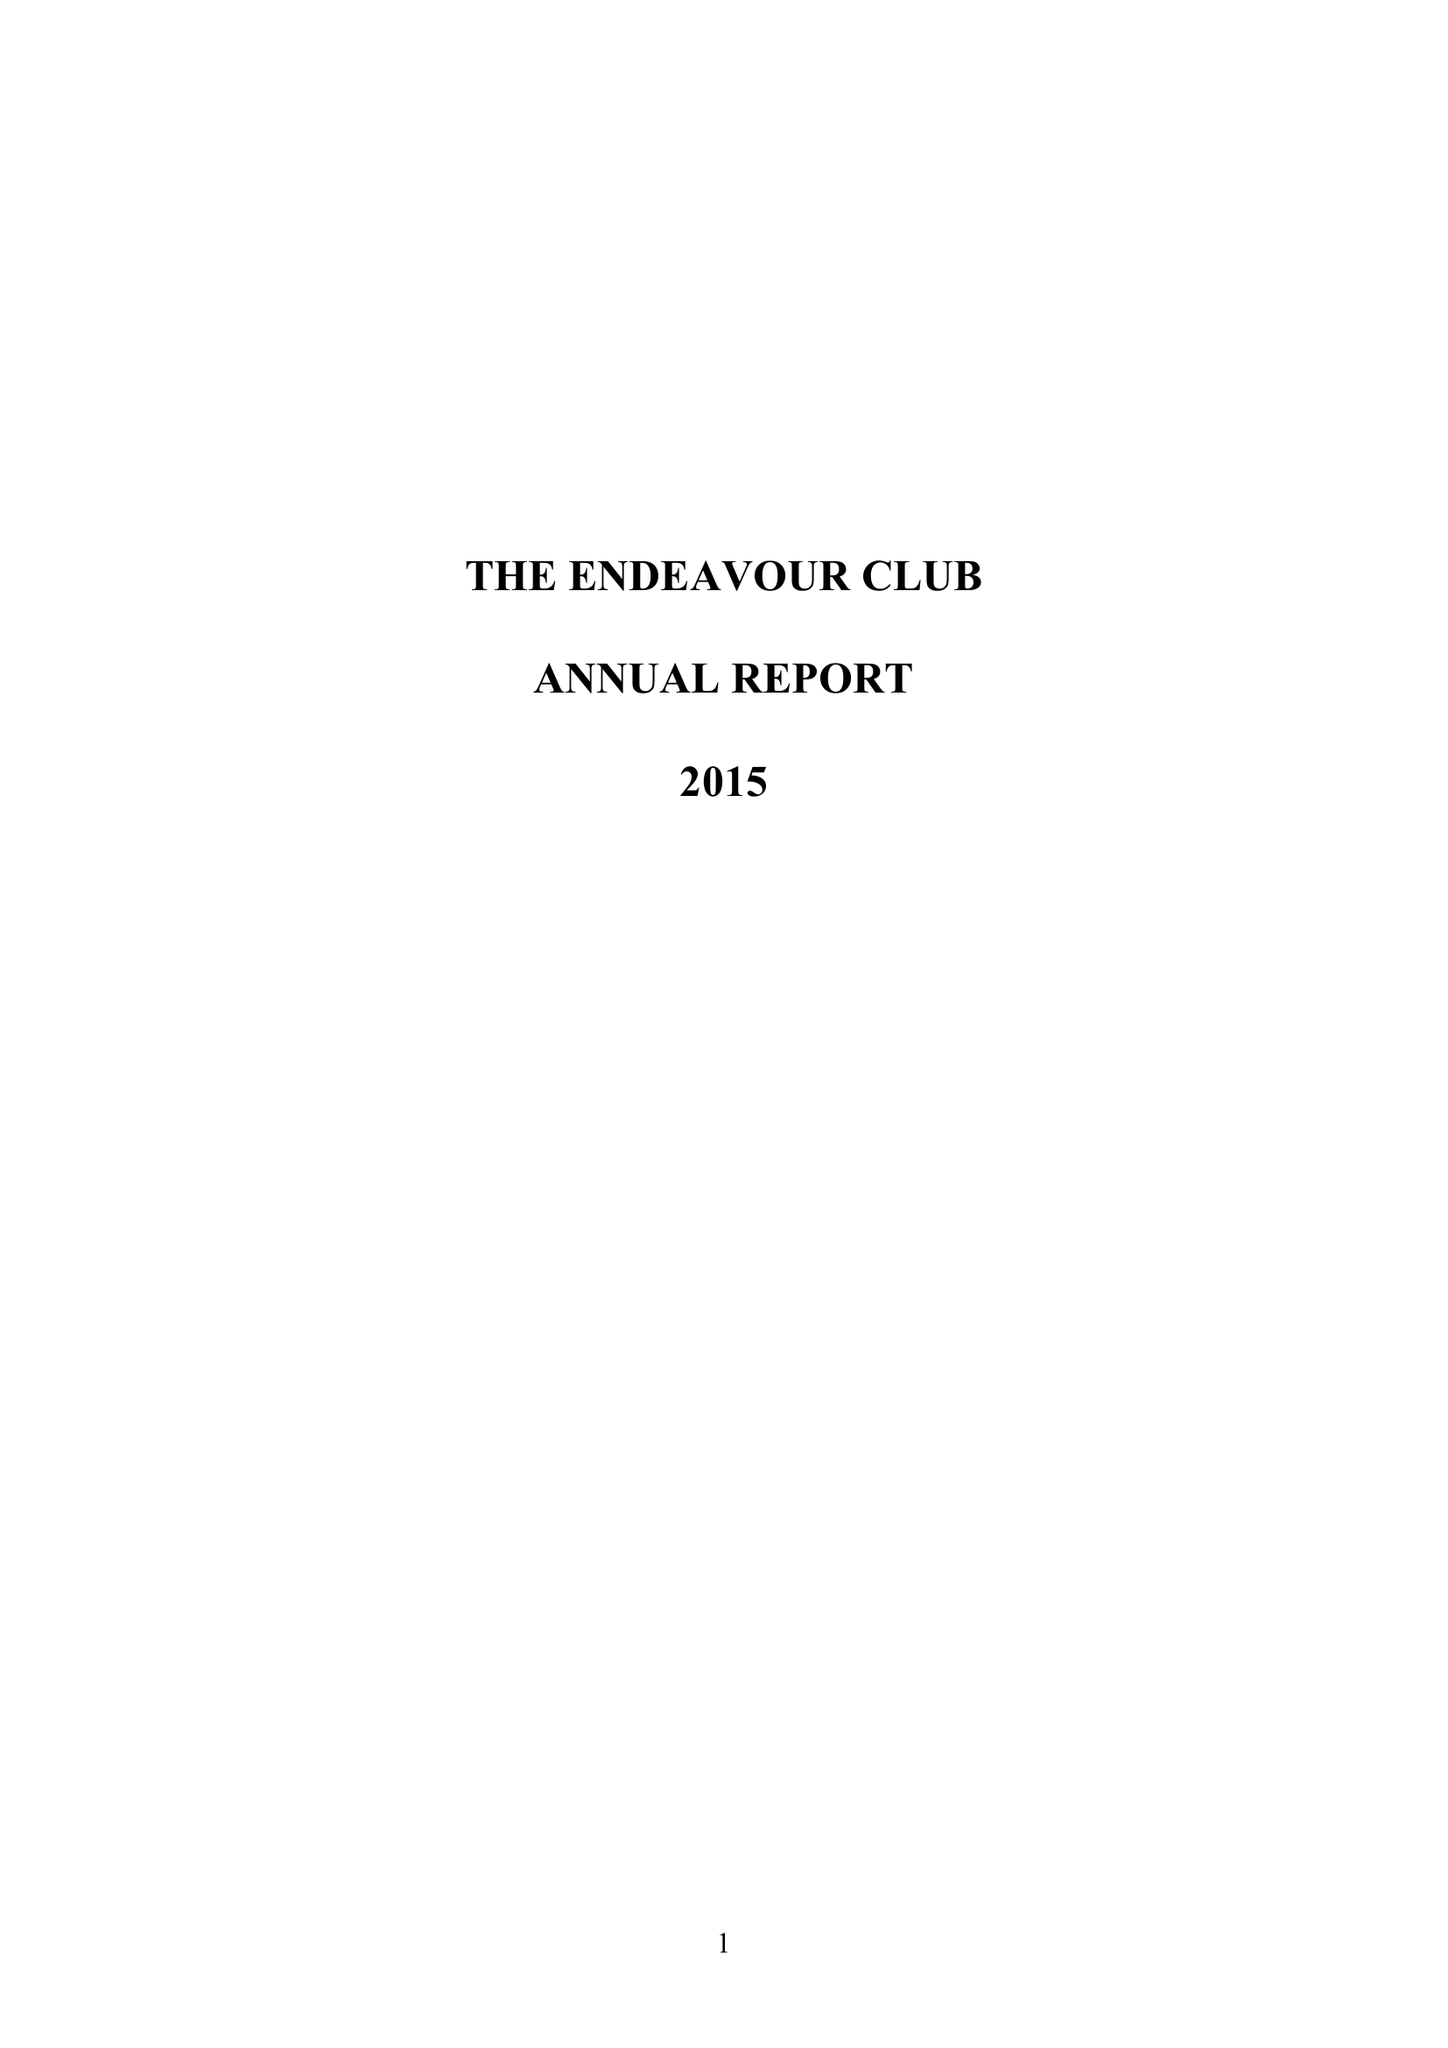What is the value for the spending_annually_in_british_pounds?
Answer the question using a single word or phrase. 77000.00 